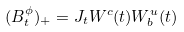Convert formula to latex. <formula><loc_0><loc_0><loc_500><loc_500>( B ^ { \phi } _ { t } ) _ { + } = J _ { t } W ^ { c } ( t ) W ^ { u } _ { b } ( t )</formula> 